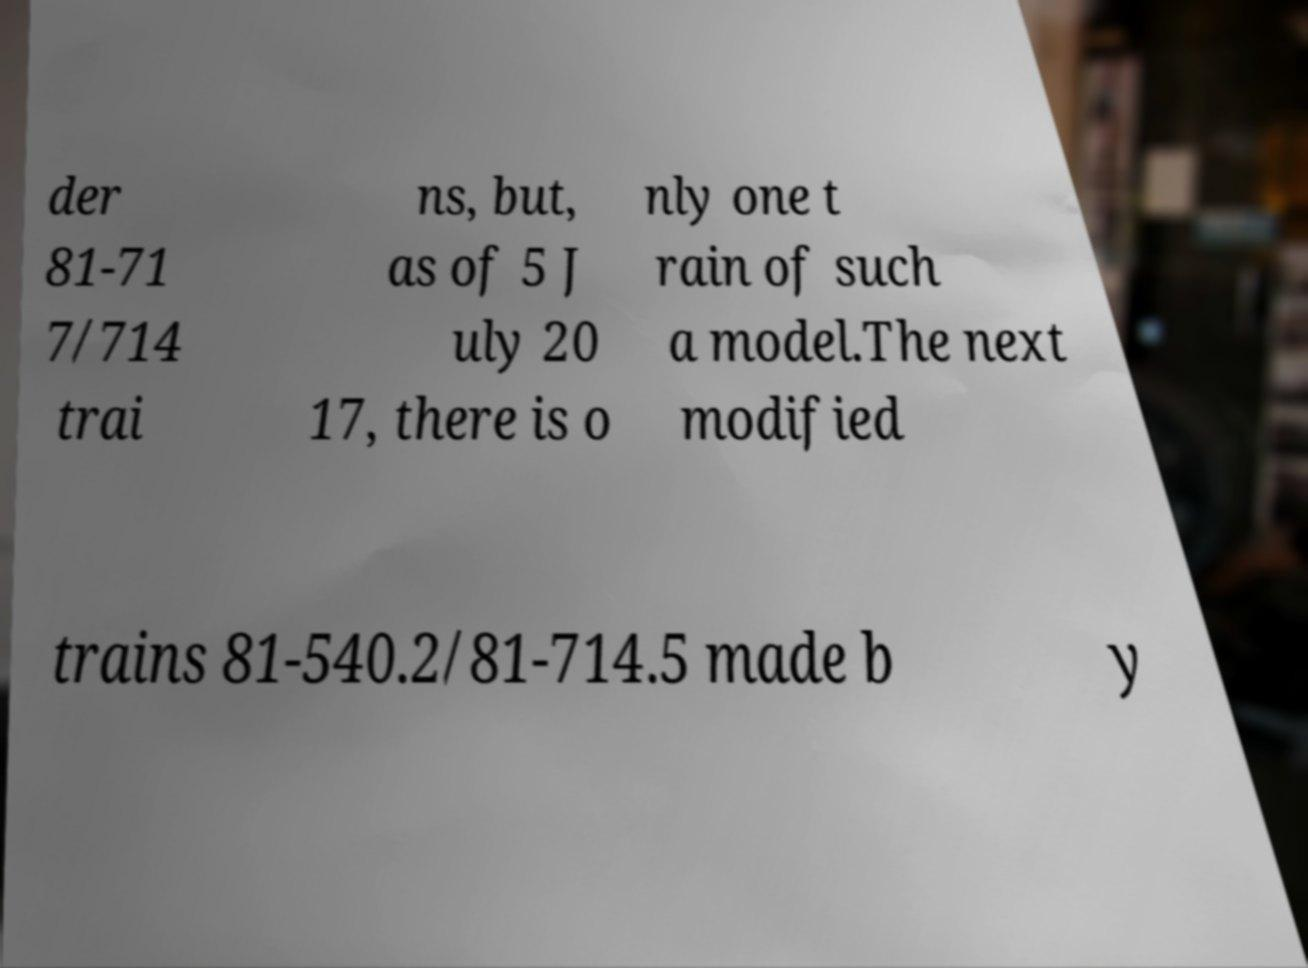What messages or text are displayed in this image? I need them in a readable, typed format. der 81-71 7/714 trai ns, but, as of 5 J uly 20 17, there is o nly one t rain of such a model.The next modified trains 81-540.2/81-714.5 made b y 